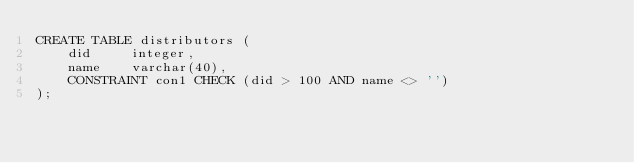Convert code to text. <code><loc_0><loc_0><loc_500><loc_500><_SQL_>CREATE TABLE distributors (
    did     integer,
    name    varchar(40),
    CONSTRAINT con1 CHECK (did > 100 AND name <> '')
);
</code> 